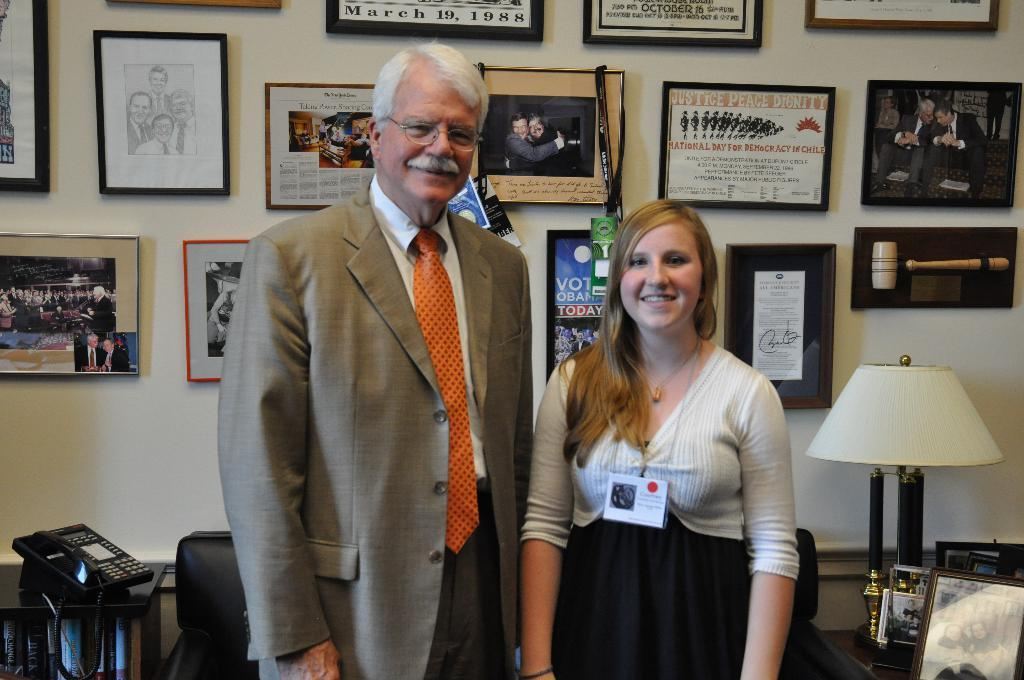<image>
Summarize the visual content of the image. Two people are standing in front of a wall of framed mementos including one from March 19, 1988. 